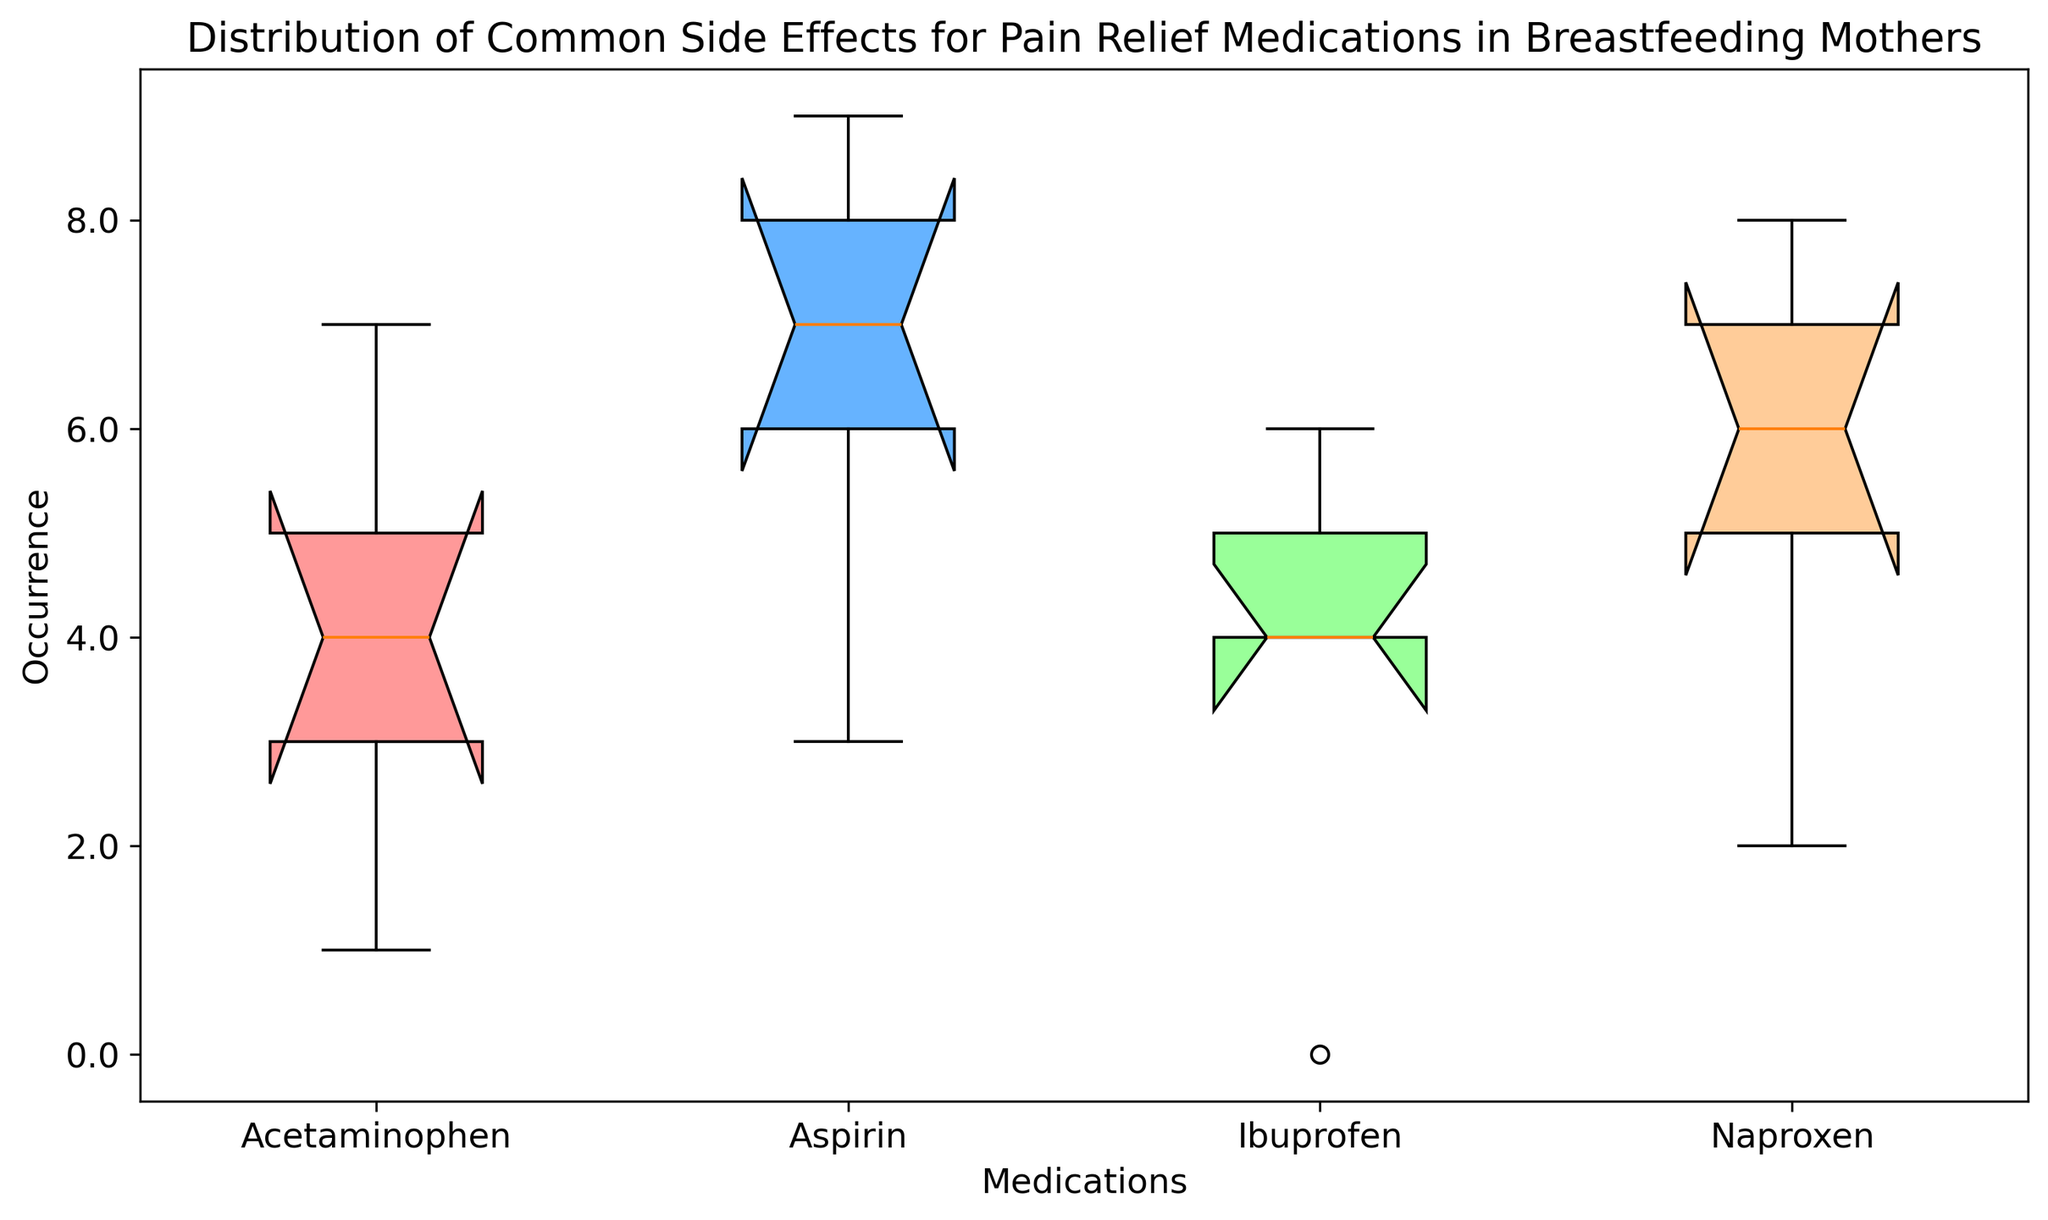What's the median occurrence of side effects for Acetaminophen? To find the median occurrence of side effects for Acetaminophen, refer to the middle value when the occurrences (1, 3, 4, 5, 7) are sorted. The median is the third value.
Answer: 4 Which medication has the highest median occurrence of side effects? Compare the median occurrence values across all medications. Acetaminophen (median 4), Ibuprofen (median 4), Naproxen (median 6), and Aspirin (median 7). Aspirin has the highest median occurrence.
Answer: Aspirin Between Ibuprofen and Naproxen, which medication shows a higher range of occurrences for side effects? Calculate the range for both medications: Range = Maximum - Minimum. Ibuprofen has occurrences (0, 4, 4, 5, 6) and its range is 6-0=6. Naproxen has occurrences (2, 5, 6, 7, 8) and its range is 8-2=6. Both have the same range.
Answer: Both have the same range Which side effect is most commonly reported across all medications? Summarize all occurrences for each side effect and find the highest sum. Fatigue (5+4+6+7=22), Nausea (7+6+8+9=30), Dizziness (3+4+5+6=18), Headache (4+5+7+8=24), AllergicReaction (1+0+2+3=6). Nausea has the highest sum of occurrences.
Answer: Nausea Which medication has the lowest median occurrence of side effects? Compare the median occurrence values across all medications. Acetaminophen (median 4), Ibuprofen (median 4), Naproxen (median 6), and Aspirin (median 7). Acetaminophen and Ibuprofen have the lowest median.
Answer: Acetaminophen and Ibuprofen What is the range of occurrences for Aspirin? Find the range by calculating the difference between the highest and lowest occurrences: Max (9), Min (3). Range = 9 - 3.
Answer: 6 Which medication has the most variable occurrence of side effects? Identify the medication with the largest difference between the highest and lowest occurrences. Acetaminophen (7-1=6), Ibuprofen (6-0=6), Naproxen (8-2=6), Aspirin (9-3=6). All have the same variability.
Answer: All have the same variability Is the occurrence of side effects for Ibuprofen consistent compared to others? Compare the spread of occurrences for Ibuprofen (0 to 6) with the ranges of other medications. Ibuprofen shows similar variability (range of 6) compared to others.
Answer: Yes How does the frequency of Allergic Reaction for Ibuprofen compare to Acetaminophen? Observing the occurrence values for Allergic Reaction: Ibuprofen (0) vs Acetaminophen (1). Allergic Reaction is less common in Ibuprofen.
Answer: Ibuprofen has fewer occurrences What color represents Naproxen in the box plot? Observe the color patterns in the box plot. The colors are listed in order Acetaminophen (red), Ibuprofen (blue), Naproxen (green), Aspirin (yellow).
Answer: Green 